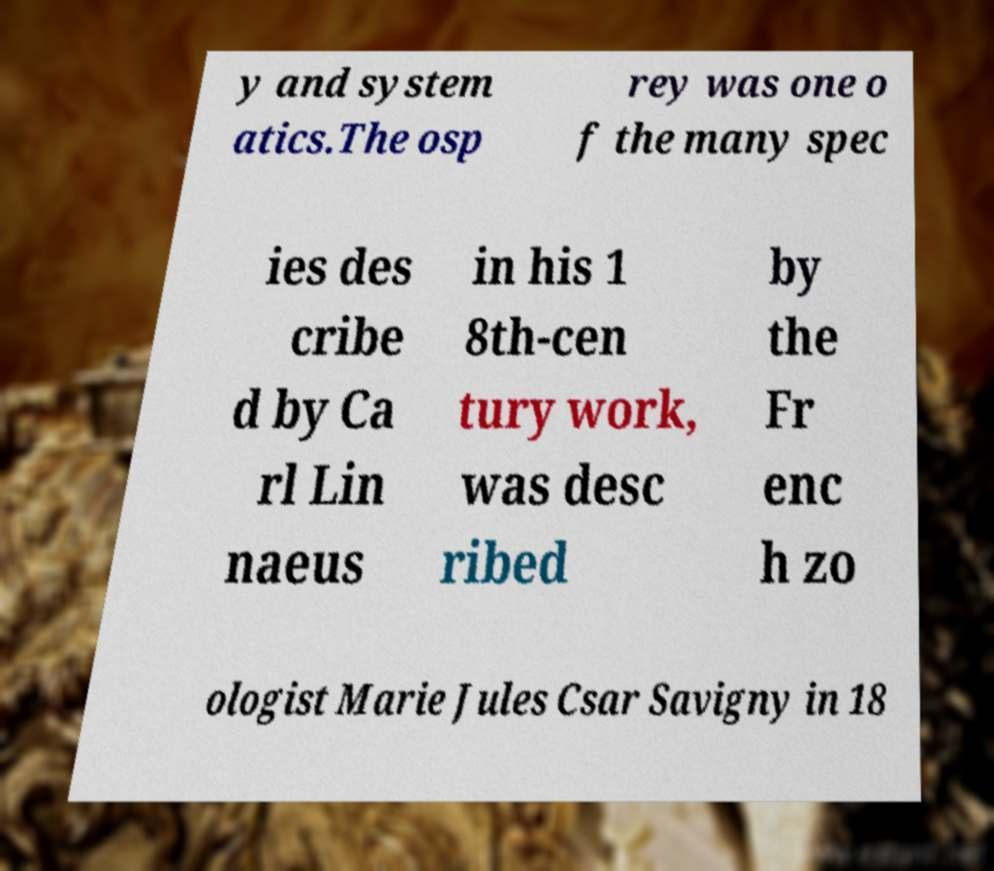I need the written content from this picture converted into text. Can you do that? y and system atics.The osp rey was one o f the many spec ies des cribe d by Ca rl Lin naeus in his 1 8th-cen tury work, was desc ribed by the Fr enc h zo ologist Marie Jules Csar Savigny in 18 